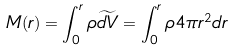Convert formula to latex. <formula><loc_0><loc_0><loc_500><loc_500>M ( r ) = \int _ { 0 } ^ { r } { \rho \widetilde { d V } } = \int _ { 0 } ^ { r } { \rho 4 \pi r ^ { 2 } d r }</formula> 